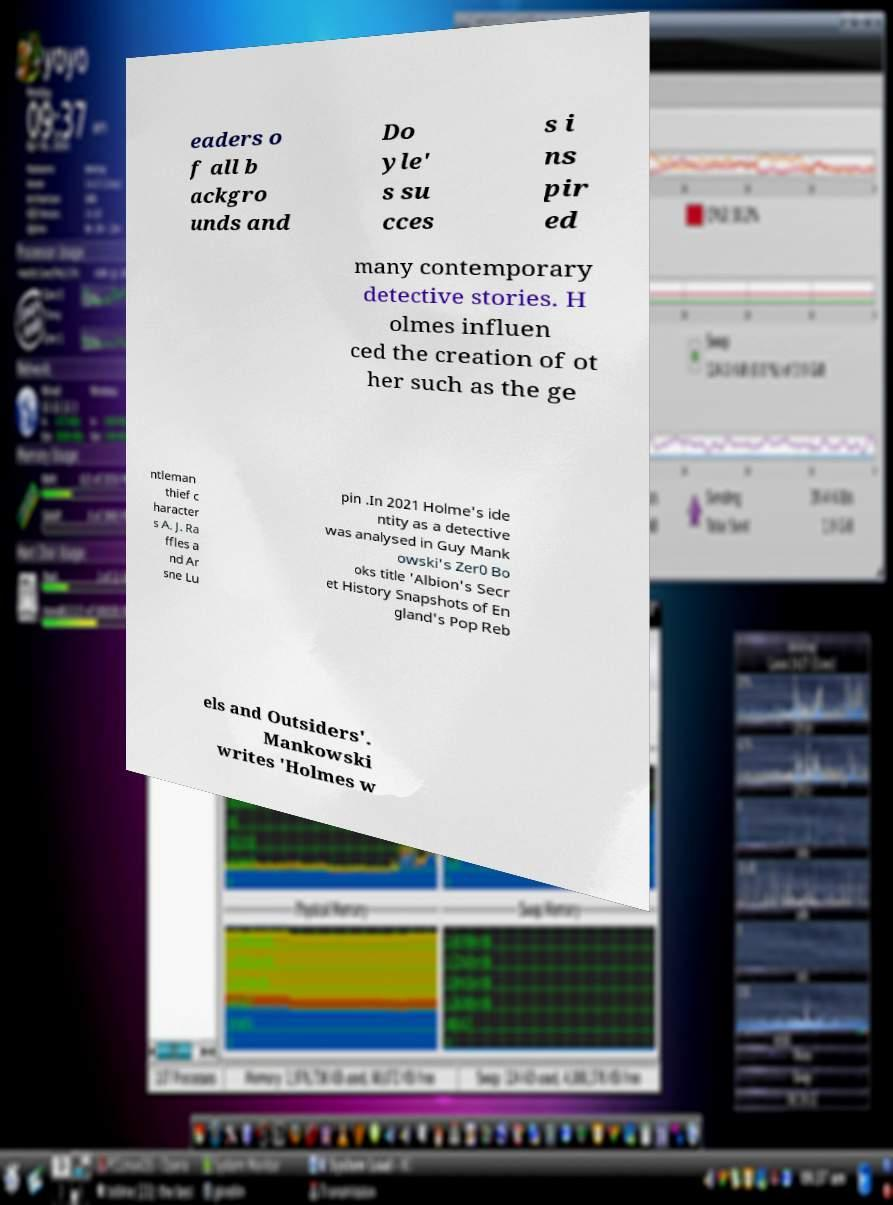Can you read and provide the text displayed in the image?This photo seems to have some interesting text. Can you extract and type it out for me? eaders o f all b ackgro unds and Do yle' s su cces s i ns pir ed many contemporary detective stories. H olmes influen ced the creation of ot her such as the ge ntleman thief c haracter s A. J. Ra ffles a nd Ar sne Lu pin .In 2021 Holme's ide ntity as a detective was analysed in Guy Mank owski's Zer0 Bo oks title 'Albion's Secr et History Snapshots of En gland's Pop Reb els and Outsiders'. Mankowski writes 'Holmes w 